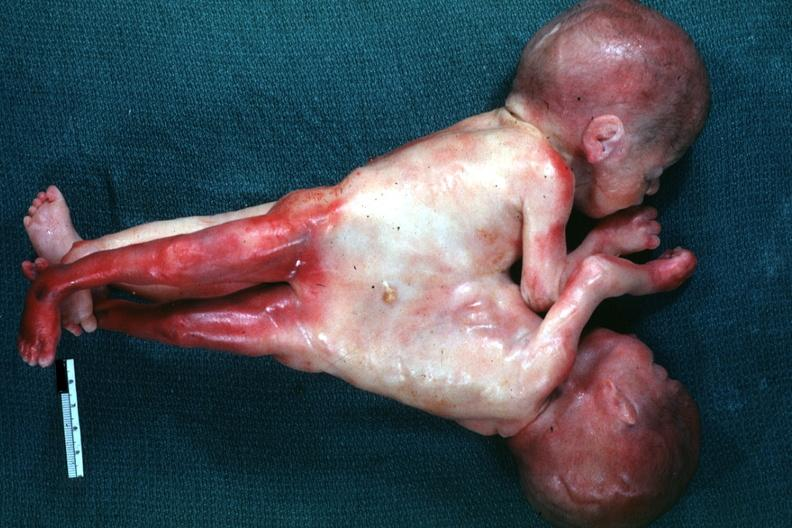does this image show lateral view joined at chest and abdomen?
Answer the question using a single word or phrase. Yes 